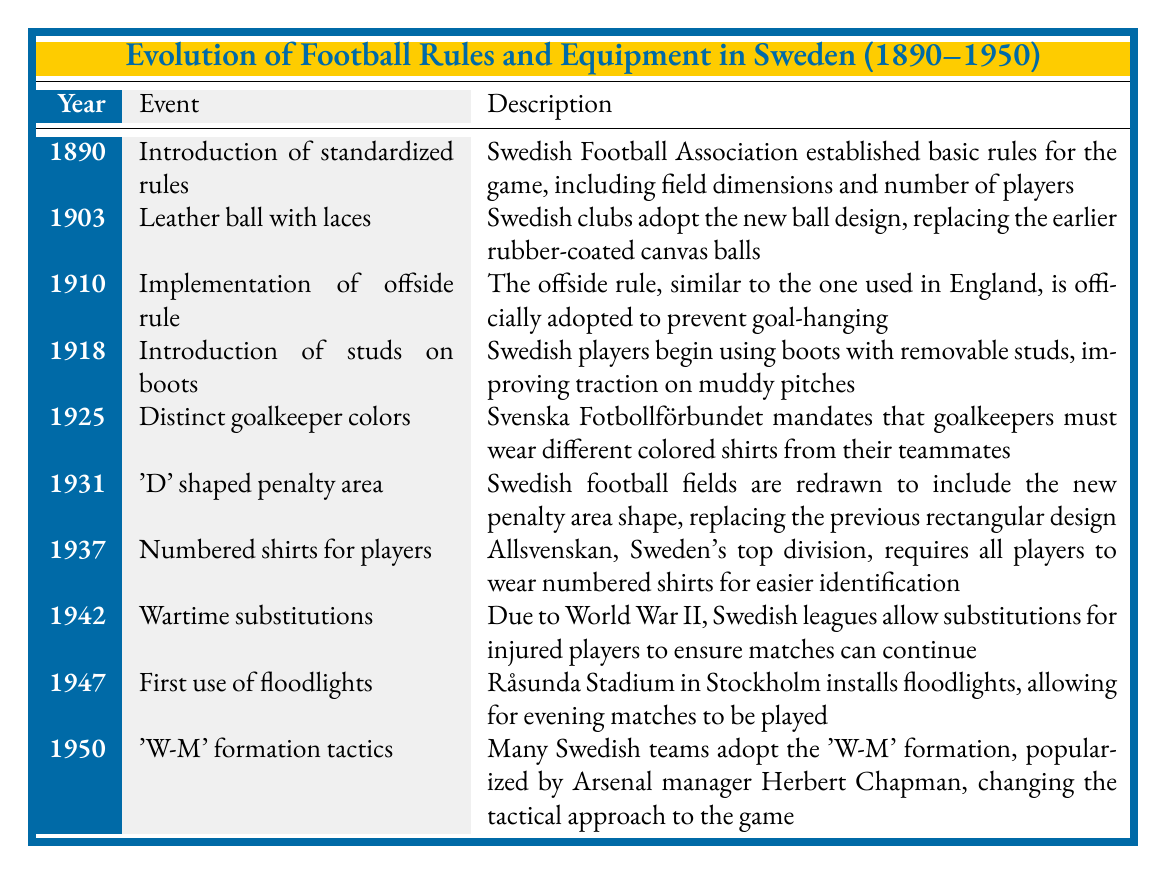What year did the Swedish Football Association establish standardized rules? The table indicates that the introduction of standardized rules in Sweden occurred in the year 1890.
Answer: 1890 What event in 1910 changed the way the game was played in Swedish leagues? In 1910, the offside rule was implemented in Swedish leagues to prevent goal-hanging, thereby altering gameplay dynamics.
Answer: Implementation of the offside rule Did Swedish players begin using boots with removable studs before or after 1918? According to the table, the introduction of studs on boots occurred in 1918, indicating that players began using them after this year.
Answer: After In what year were substitutions allowed during wartime in Swedish leagues? The table specifies that substitutions for injured players during World War II were implemented in 1942.
Answer: 1942 What were the requirements for goalkeepers in 1925 according to the table? The table states that in 1925, Svenska Fotbollförbundet mandated that goalkeepers must wear shirts of distinct colors compared to their teammates for better identification.
Answer: Goalkeepers must wear different colored shirts How many significant changes to rules or equipment occurred between 1910 and 1937? Analyzing the table, notable changes between those years include: implementation of the offside rule in 1910, introduction of studs on boots in 1918, distinct goalkeeper colors in 1925, and numbered shirts for players in 1937. This results in a total of four significant changes.
Answer: Four changes What was the first stadium to install floodlights, and when did this occur? The table indicates that Råsunda Stadium in Stockholm was the first to install floodlights in 1947, enabling evening matches.
Answer: Råsunda Stadium in 1947 Which event occurred directly after the introduction of the 'D' shaped penalty area? The introduction of the 'D' shaped penalty area occurred in 1931, and the next event in the table is the introduction of numbered shirts for players in 1937, indicating that the latter event occurred directly after.
Answer: Introduction of numbered shirts in 1937 What significant tactical change occurred in Swedish football by 1950? The table reveals that in 1950, many Swedish teams adopted the 'W-M' formation, a tactical change popularized by Arsenal manager Herbert Chapman.
Answer: Adoption of the 'W-M' formation 